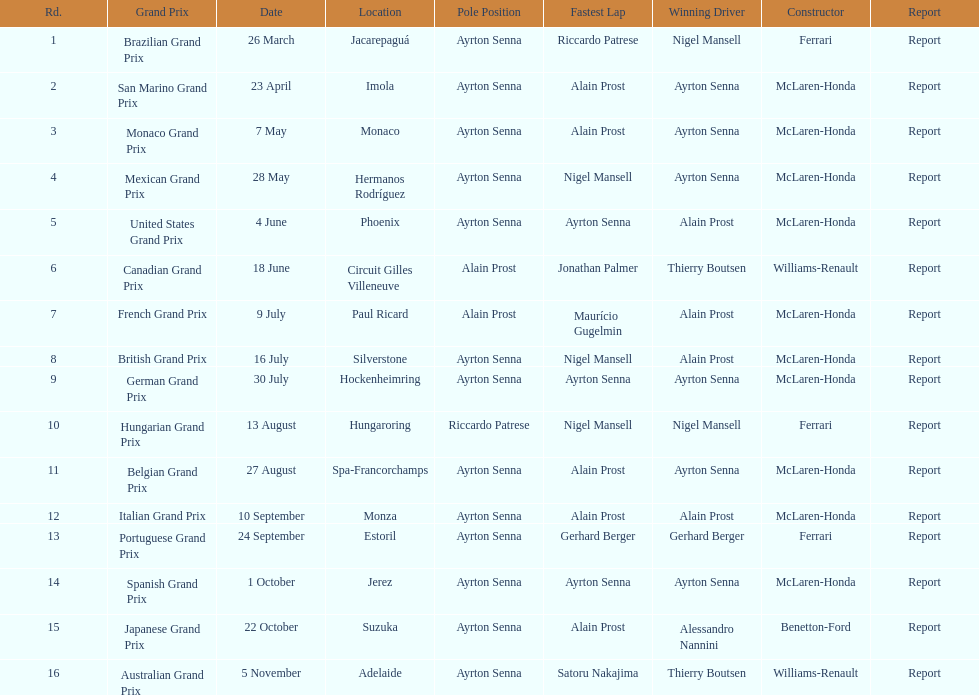What grand prix was before the san marino grand prix? Brazilian Grand Prix. 